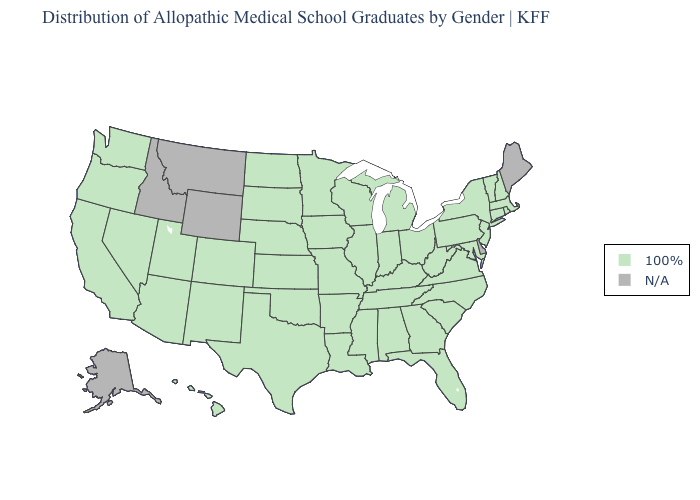Name the states that have a value in the range N/A?
Quick response, please. Alaska, Delaware, Idaho, Maine, Montana, Wyoming. Is the legend a continuous bar?
Concise answer only. No. Which states have the lowest value in the South?
Be succinct. Alabama, Arkansas, Florida, Georgia, Kentucky, Louisiana, Maryland, Mississippi, North Carolina, Oklahoma, South Carolina, Tennessee, Texas, Virginia, West Virginia. What is the lowest value in the South?
Short answer required. 100%. Does the map have missing data?
Concise answer only. Yes. What is the value of New Mexico?
Be succinct. 100%. Name the states that have a value in the range N/A?
Quick response, please. Alaska, Delaware, Idaho, Maine, Montana, Wyoming. What is the value of North Dakota?
Give a very brief answer. 100%. What is the value of Ohio?
Answer briefly. 100%. What is the highest value in the South ?
Keep it brief. 100%. Does the map have missing data?
Short answer required. Yes. Which states have the highest value in the USA?
Write a very short answer. Alabama, Arizona, Arkansas, California, Colorado, Connecticut, Florida, Georgia, Hawaii, Illinois, Indiana, Iowa, Kansas, Kentucky, Louisiana, Maryland, Massachusetts, Michigan, Minnesota, Mississippi, Missouri, Nebraska, Nevada, New Hampshire, New Jersey, New Mexico, New York, North Carolina, North Dakota, Ohio, Oklahoma, Oregon, Pennsylvania, Rhode Island, South Carolina, South Dakota, Tennessee, Texas, Utah, Vermont, Virginia, Washington, West Virginia, Wisconsin. Among the states that border New Hampshire , which have the lowest value?
Keep it brief. Massachusetts, Vermont. What is the highest value in the USA?
Write a very short answer. 100%. 